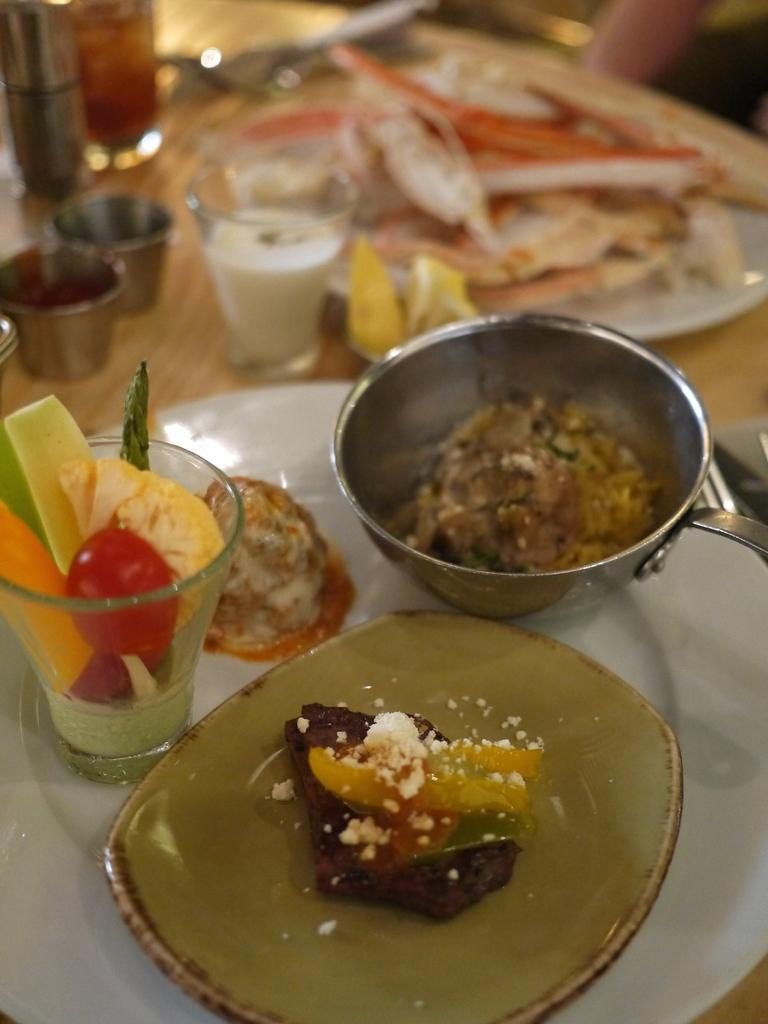What is on the plate in the image? There are food items on a plate in the image. What can be seen on the table in the image? There are glasses and other objects on the table in the image. How many snails can be seen crawling on the food items in the image? There are no snails present in the image. What type of card is visible on the table in the image? There is no card visible on the table in the image. 